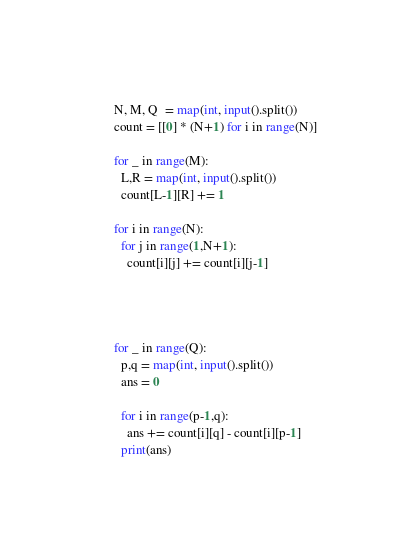Convert code to text. <code><loc_0><loc_0><loc_500><loc_500><_Python_>N, M, Q  = map(int, input().split())
count = [[0] * (N+1) for i in range(N)]

for _ in range(M):
  L,R = map(int, input().split())
  count[L-1][R] += 1

for i in range(N):
  for j in range(1,N+1):
    count[i][j] += count[i][j-1]




for _ in range(Q):
  p,q = map(int, input().split())
  ans = 0

  for i in range(p-1,q):
    ans += count[i][q] - count[i][p-1]
  print(ans)</code> 